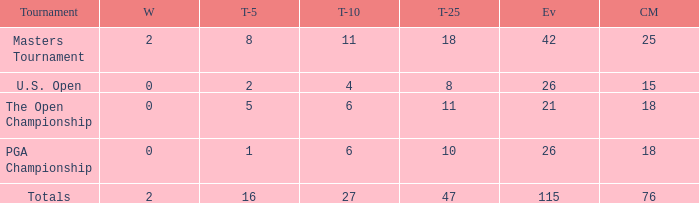What is the combined total of successful outcomes when 76 cuts are executed and instances are more than 115? None. 